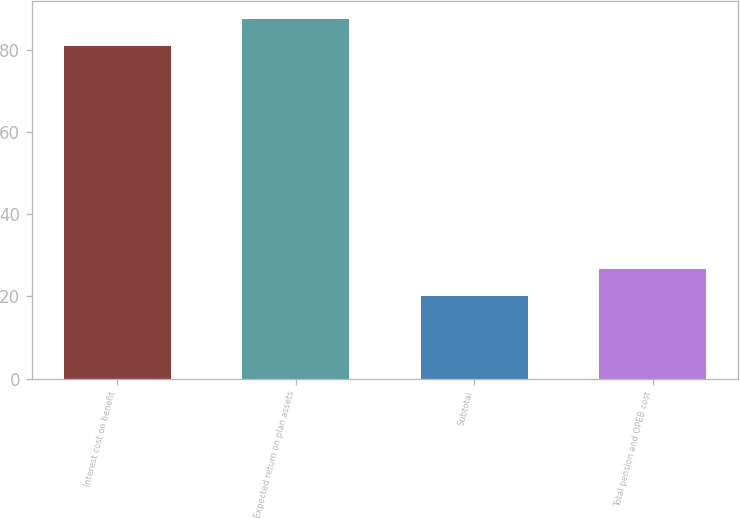Convert chart. <chart><loc_0><loc_0><loc_500><loc_500><bar_chart><fcel>Interest cost on benefit<fcel>Expected return on plan assets<fcel>Subtotal<fcel>Total pension and OPEB cost<nl><fcel>81<fcel>87.6<fcel>20<fcel>26.6<nl></chart> 